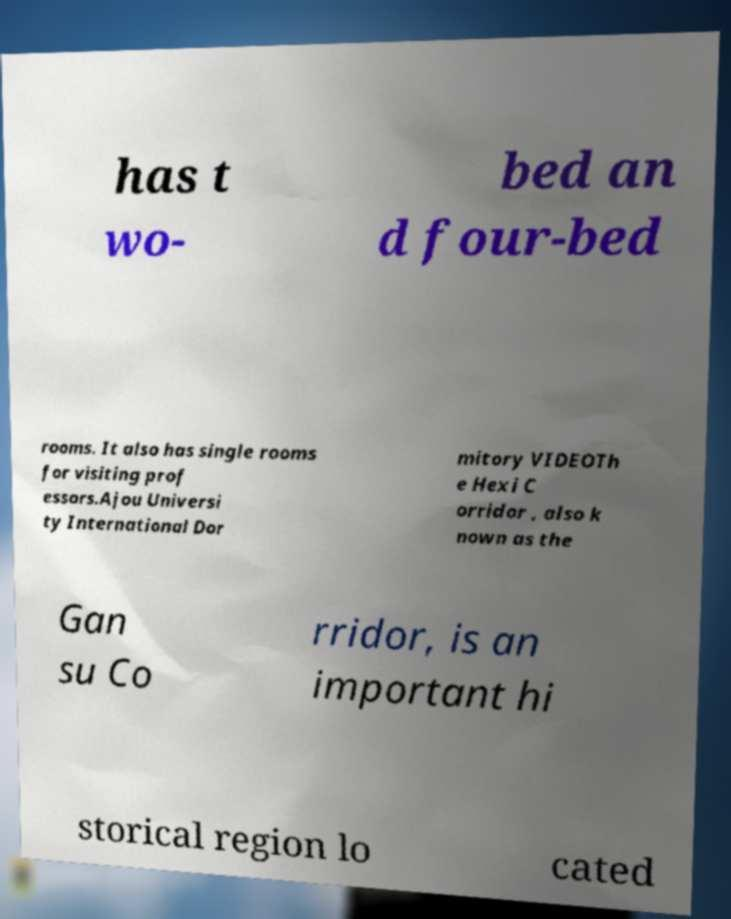There's text embedded in this image that I need extracted. Can you transcribe it verbatim? has t wo- bed an d four-bed rooms. It also has single rooms for visiting prof essors.Ajou Universi ty International Dor mitory VIDEOTh e Hexi C orridor , also k nown as the Gan su Co rridor, is an important hi storical region lo cated 